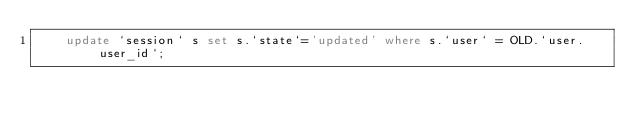Convert code to text. <code><loc_0><loc_0><loc_500><loc_500><_SQL_>		update `session` s set s.`state`='updated' where s.`user` = OLD.`user.user_id`;</code> 